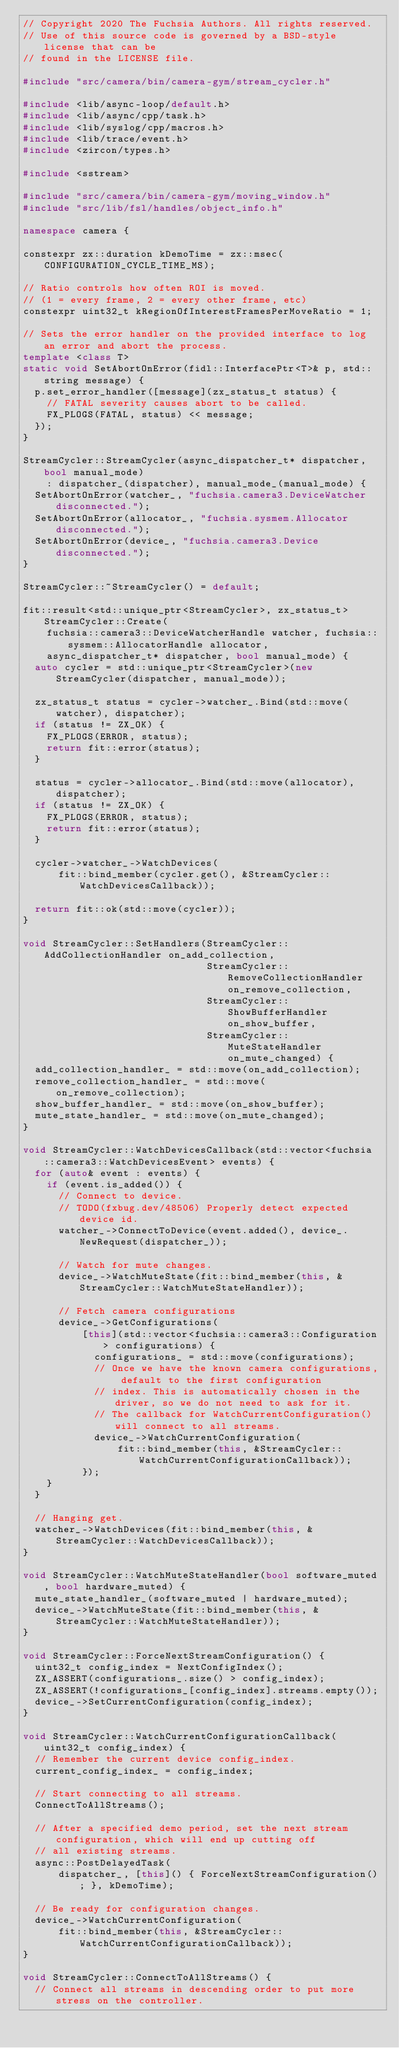<code> <loc_0><loc_0><loc_500><loc_500><_C++_>// Copyright 2020 The Fuchsia Authors. All rights reserved.
// Use of this source code is governed by a BSD-style license that can be
// found in the LICENSE file.

#include "src/camera/bin/camera-gym/stream_cycler.h"

#include <lib/async-loop/default.h>
#include <lib/async/cpp/task.h>
#include <lib/syslog/cpp/macros.h>
#include <lib/trace/event.h>
#include <zircon/types.h>

#include <sstream>

#include "src/camera/bin/camera-gym/moving_window.h"
#include "src/lib/fsl/handles/object_info.h"

namespace camera {

constexpr zx::duration kDemoTime = zx::msec(CONFIGURATION_CYCLE_TIME_MS);

// Ratio controls how often ROI is moved.
// (1 = every frame, 2 = every other frame, etc)
constexpr uint32_t kRegionOfInterestFramesPerMoveRatio = 1;

// Sets the error handler on the provided interface to log an error and abort the process.
template <class T>
static void SetAbortOnError(fidl::InterfacePtr<T>& p, std::string message) {
  p.set_error_handler([message](zx_status_t status) {
    // FATAL severity causes abort to be called.
    FX_PLOGS(FATAL, status) << message;
  });
}

StreamCycler::StreamCycler(async_dispatcher_t* dispatcher, bool manual_mode)
    : dispatcher_(dispatcher), manual_mode_(manual_mode) {
  SetAbortOnError(watcher_, "fuchsia.camera3.DeviceWatcher disconnected.");
  SetAbortOnError(allocator_, "fuchsia.sysmem.Allocator disconnected.");
  SetAbortOnError(device_, "fuchsia.camera3.Device disconnected.");
}

StreamCycler::~StreamCycler() = default;

fit::result<std::unique_ptr<StreamCycler>, zx_status_t> StreamCycler::Create(
    fuchsia::camera3::DeviceWatcherHandle watcher, fuchsia::sysmem::AllocatorHandle allocator,
    async_dispatcher_t* dispatcher, bool manual_mode) {
  auto cycler = std::unique_ptr<StreamCycler>(new StreamCycler(dispatcher, manual_mode));

  zx_status_t status = cycler->watcher_.Bind(std::move(watcher), dispatcher);
  if (status != ZX_OK) {
    FX_PLOGS(ERROR, status);
    return fit::error(status);
  }

  status = cycler->allocator_.Bind(std::move(allocator), dispatcher);
  if (status != ZX_OK) {
    FX_PLOGS(ERROR, status);
    return fit::error(status);
  }

  cycler->watcher_->WatchDevices(
      fit::bind_member(cycler.get(), &StreamCycler::WatchDevicesCallback));

  return fit::ok(std::move(cycler));
}

void StreamCycler::SetHandlers(StreamCycler::AddCollectionHandler on_add_collection,
                               StreamCycler::RemoveCollectionHandler on_remove_collection,
                               StreamCycler::ShowBufferHandler on_show_buffer,
                               StreamCycler::MuteStateHandler on_mute_changed) {
  add_collection_handler_ = std::move(on_add_collection);
  remove_collection_handler_ = std::move(on_remove_collection);
  show_buffer_handler_ = std::move(on_show_buffer);
  mute_state_handler_ = std::move(on_mute_changed);
}

void StreamCycler::WatchDevicesCallback(std::vector<fuchsia::camera3::WatchDevicesEvent> events) {
  for (auto& event : events) {
    if (event.is_added()) {
      // Connect to device.
      // TODO(fxbug.dev/48506) Properly detect expected device id.
      watcher_->ConnectToDevice(event.added(), device_.NewRequest(dispatcher_));

      // Watch for mute changes.
      device_->WatchMuteState(fit::bind_member(this, &StreamCycler::WatchMuteStateHandler));

      // Fetch camera configurations
      device_->GetConfigurations(
          [this](std::vector<fuchsia::camera3::Configuration> configurations) {
            configurations_ = std::move(configurations);
            // Once we have the known camera configurations, default to the first configuration
            // index. This is automatically chosen in the driver, so we do not need to ask for it.
            // The callback for WatchCurrentConfiguration() will connect to all streams.
            device_->WatchCurrentConfiguration(
                fit::bind_member(this, &StreamCycler::WatchCurrentConfigurationCallback));
          });
    }
  }

  // Hanging get.
  watcher_->WatchDevices(fit::bind_member(this, &StreamCycler::WatchDevicesCallback));
}

void StreamCycler::WatchMuteStateHandler(bool software_muted, bool hardware_muted) {
  mute_state_handler_(software_muted | hardware_muted);
  device_->WatchMuteState(fit::bind_member(this, &StreamCycler::WatchMuteStateHandler));
}

void StreamCycler::ForceNextStreamConfiguration() {
  uint32_t config_index = NextConfigIndex();
  ZX_ASSERT(configurations_.size() > config_index);
  ZX_ASSERT(!configurations_[config_index].streams.empty());
  device_->SetCurrentConfiguration(config_index);
}

void StreamCycler::WatchCurrentConfigurationCallback(uint32_t config_index) {
  // Remember the current device config_index.
  current_config_index_ = config_index;

  // Start connecting to all streams.
  ConnectToAllStreams();

  // After a specified demo period, set the next stream configuration, which will end up cutting off
  // all existing streams.
  async::PostDelayedTask(
      dispatcher_, [this]() { ForceNextStreamConfiguration(); }, kDemoTime);

  // Be ready for configuration changes.
  device_->WatchCurrentConfiguration(
      fit::bind_member(this, &StreamCycler::WatchCurrentConfigurationCallback));
}

void StreamCycler::ConnectToAllStreams() {
  // Connect all streams in descending order to put more stress on the controller.</code> 